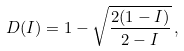<formula> <loc_0><loc_0><loc_500><loc_500>D ( I ) = 1 - \sqrt { \frac { 2 ( 1 - I ) } { 2 - I } } \, ,</formula> 